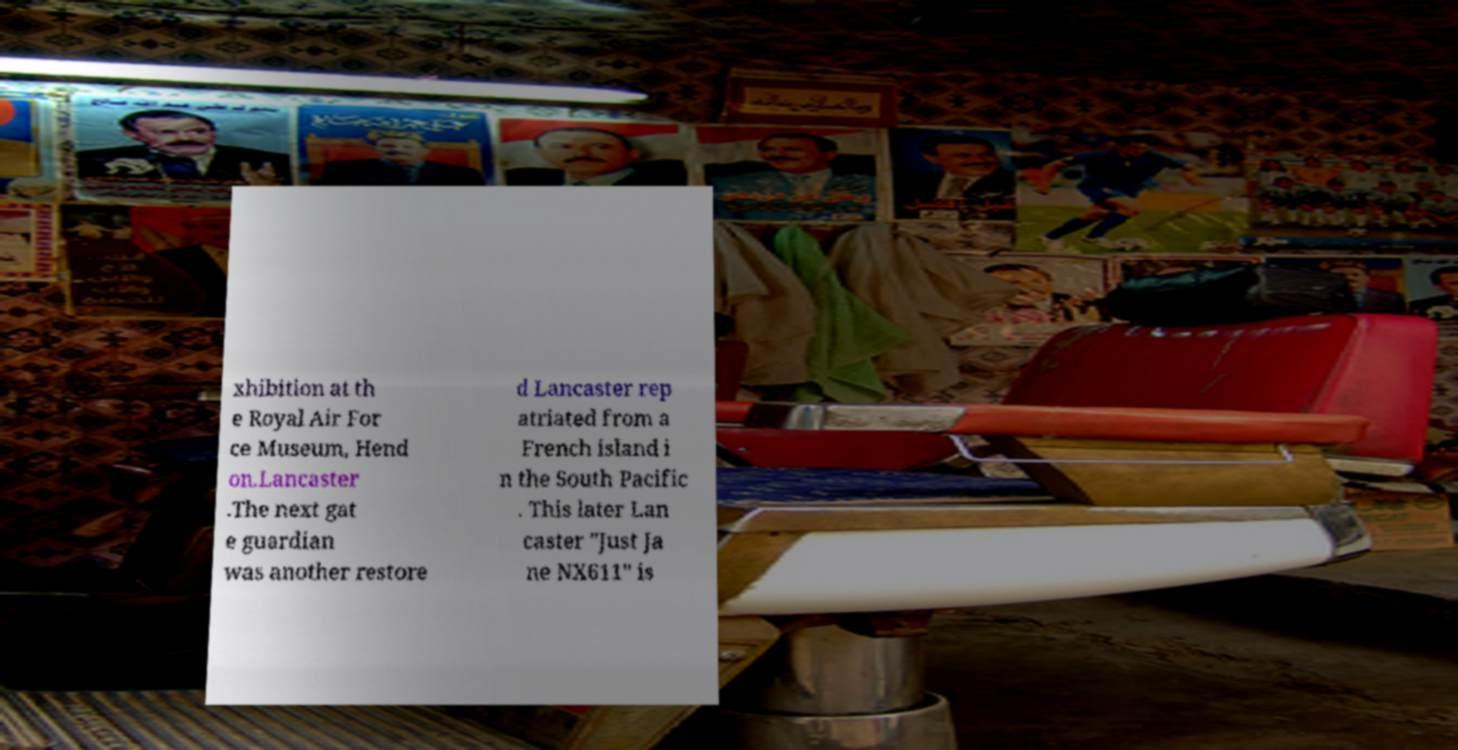There's text embedded in this image that I need extracted. Can you transcribe it verbatim? xhibition at th e Royal Air For ce Museum, Hend on.Lancaster .The next gat e guardian was another restore d Lancaster rep atriated from a French island i n the South Pacific . This later Lan caster "Just Ja ne NX611" is 